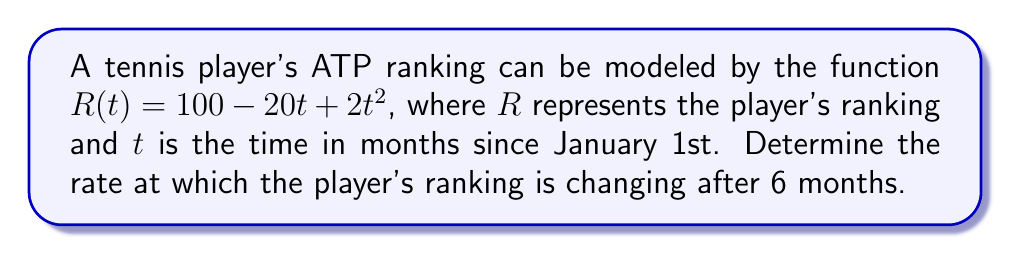Give your solution to this math problem. To find the rate of change in the player's ATP ranking after 6 months, we need to follow these steps:

1. The given function for the player's ranking is:
   $R(t) = 100 - 20t + 2t^2$

2. To find the rate of change, we need to calculate the derivative of $R(t)$ with respect to $t$:
   $$\frac{dR}{dt} = \frac{d}{dt}(100 - 20t + 2t^2)$$

3. Using the power rule and constant rule of differentiation:
   $$\frac{dR}{dt} = 0 - 20 + 4t$$

4. Simplify:
   $$\frac{dR}{dt} = 4t - 20$$

5. To find the rate of change after 6 months, we substitute $t = 6$ into the derivative:
   $$\frac{dR}{dt}\bigg|_{t=6} = 4(6) - 20 = 24 - 20 = 4$$

6. Interpret the result: The positive value indicates that the player's ranking is improving (remember that a lower numerical rank is better in tennis).
Answer: $4$ ranking positions per month 